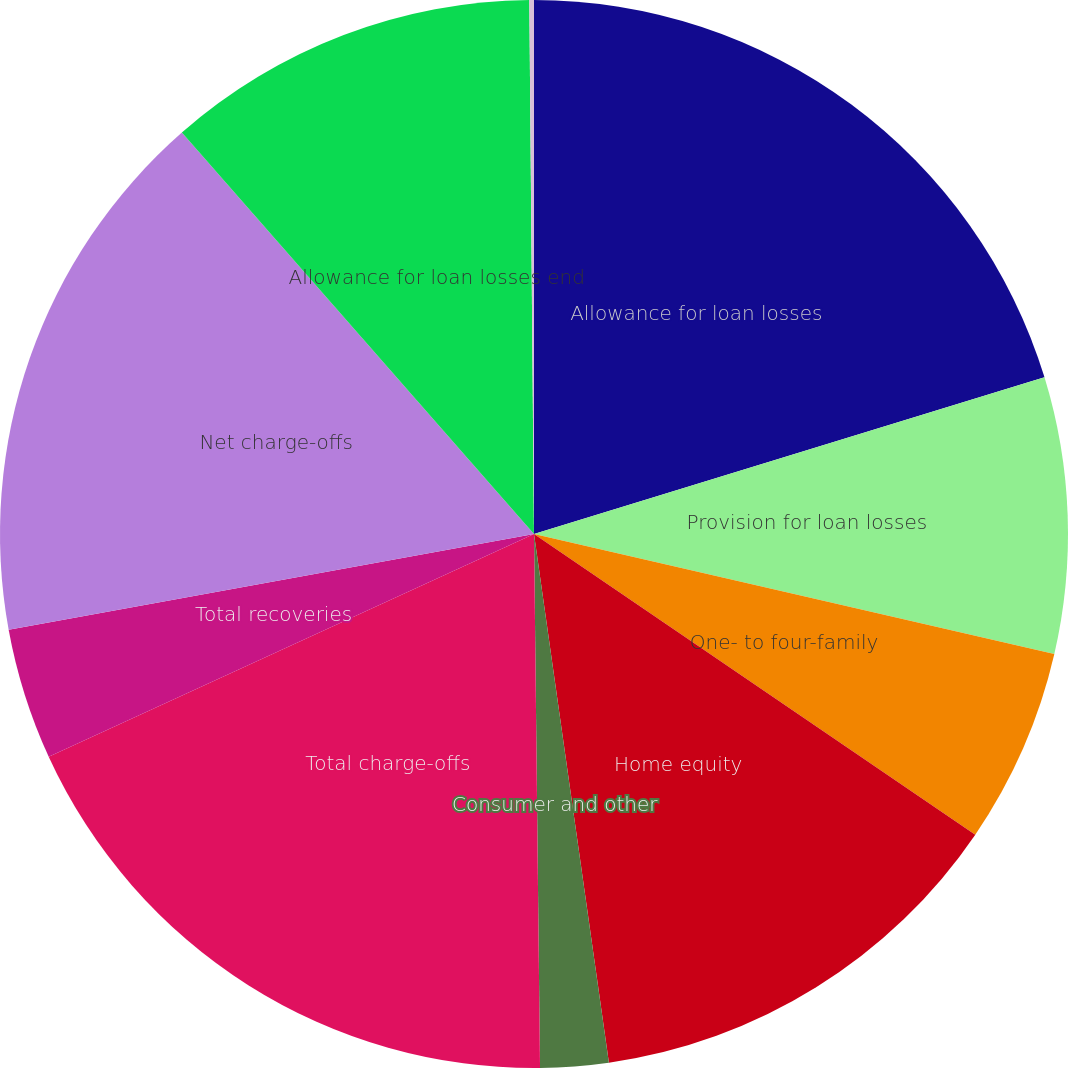Convert chart to OTSL. <chart><loc_0><loc_0><loc_500><loc_500><pie_chart><fcel>Allowance for loan losses<fcel>Provision for loan losses<fcel>One- to four-family<fcel>Home equity<fcel>Consumer and other<fcel>Total charge-offs<fcel>Total recoveries<fcel>Net charge-offs<fcel>Allowance for loan losses end<fcel>Net charge-offs to average<nl><fcel>20.26%<fcel>8.35%<fcel>5.91%<fcel>13.24%<fcel>2.06%<fcel>18.33%<fcel>3.98%<fcel>16.41%<fcel>11.32%<fcel>0.14%<nl></chart> 